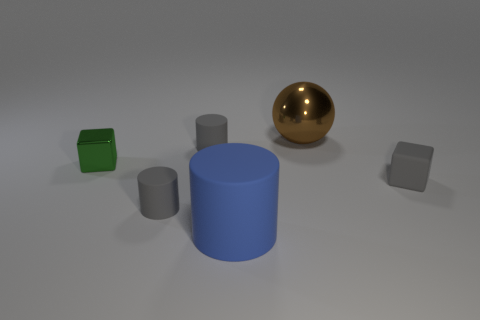Subtract all gray rubber cylinders. How many cylinders are left? 1 Add 3 large blue matte objects. How many objects exist? 9 Subtract all blue cylinders. How many cylinders are left? 2 Subtract all spheres. How many objects are left? 5 Subtract 0 cyan blocks. How many objects are left? 6 Subtract 2 blocks. How many blocks are left? 0 Subtract all yellow blocks. Subtract all cyan balls. How many blocks are left? 2 Subtract all blue blocks. How many gray cylinders are left? 2 Subtract all tiny matte cubes. Subtract all blue rubber things. How many objects are left? 4 Add 2 blue objects. How many blue objects are left? 3 